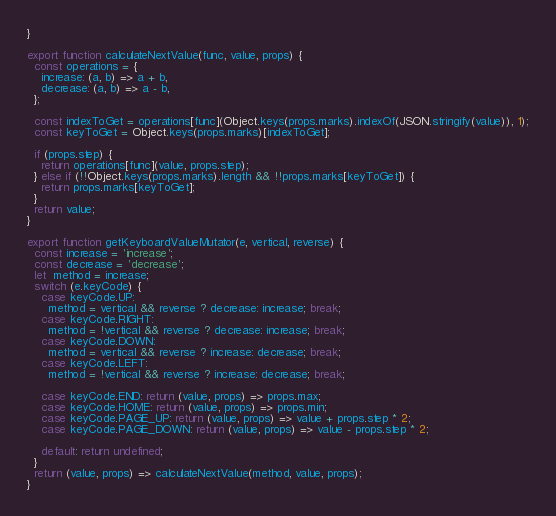<code> <loc_0><loc_0><loc_500><loc_500><_JavaScript_>}

export function calculateNextValue(func, value, props) {
  const operations = {
    increase: (a, b) => a + b,
    decrease: (a, b) => a - b,
  };

  const indexToGet = operations[func](Object.keys(props.marks).indexOf(JSON.stringify(value)), 1);
  const keyToGet = Object.keys(props.marks)[indexToGet];

  if (props.step) {
    return operations[func](value, props.step);
  } else if (!!Object.keys(props.marks).length && !!props.marks[keyToGet]) {
    return props.marks[keyToGet];
  }
  return value;
}

export function getKeyboardValueMutator(e, vertical, reverse) {
  const increase = 'increase';
  const decrease = 'decrease';
  let  method = increase;
  switch (e.keyCode) {
    case keyCode.UP:
      method = vertical && reverse ? decrease: increase; break;
    case keyCode.RIGHT:
      method = !vertical && reverse ? decrease: increase; break;
    case keyCode.DOWN:
      method = vertical && reverse ? increase: decrease; break;
    case keyCode.LEFT:
      method = !vertical && reverse ? increase: decrease; break;

    case keyCode.END: return (value, props) => props.max;
    case keyCode.HOME: return (value, props) => props.min;
    case keyCode.PAGE_UP: return (value, props) => value + props.step * 2;
    case keyCode.PAGE_DOWN: return (value, props) => value - props.step * 2;

    default: return undefined;
  }
  return (value, props) => calculateNextValue(method, value, props);
}
</code> 